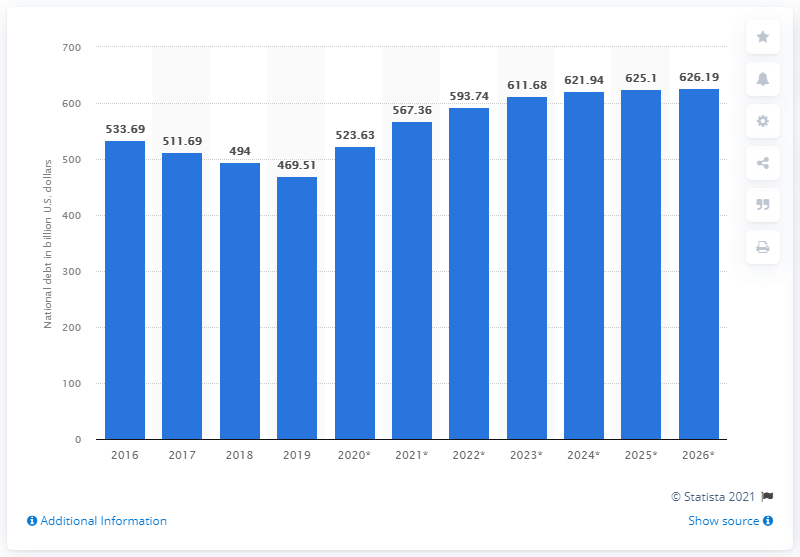Draw attention to some important aspects in this diagram. In 2019, the national debt of the Netherlands was 469.51. 